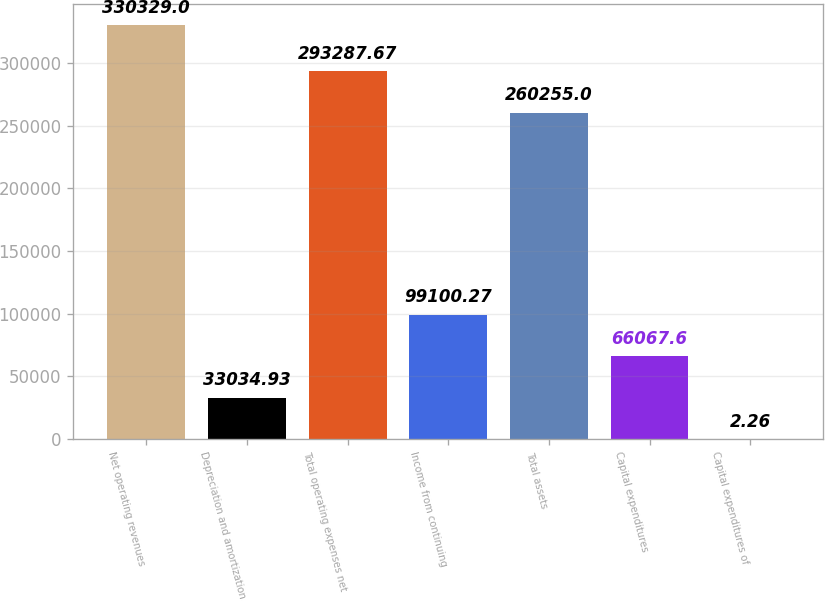Convert chart. <chart><loc_0><loc_0><loc_500><loc_500><bar_chart><fcel>Net operating revenues<fcel>Depreciation and amortization<fcel>Total operating expenses net<fcel>Income from continuing<fcel>Total assets<fcel>Capital expenditures<fcel>Capital expenditures of<nl><fcel>330329<fcel>33034.9<fcel>293288<fcel>99100.3<fcel>260255<fcel>66067.6<fcel>2.26<nl></chart> 